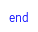<code> <loc_0><loc_0><loc_500><loc_500><_Ruby_>end
</code> 